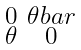Convert formula to latex. <formula><loc_0><loc_0><loc_500><loc_500>\begin{smallmatrix} 0 & \theta b a r \\ \theta & 0 \end{smallmatrix}</formula> 